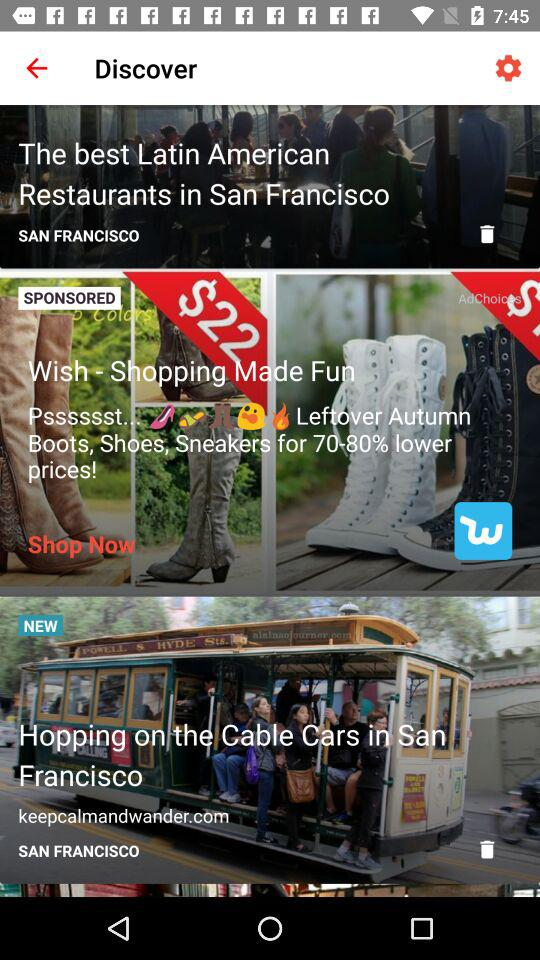What's the City name for discover?
When the provided information is insufficient, respond with <no answer>. <no answer> 